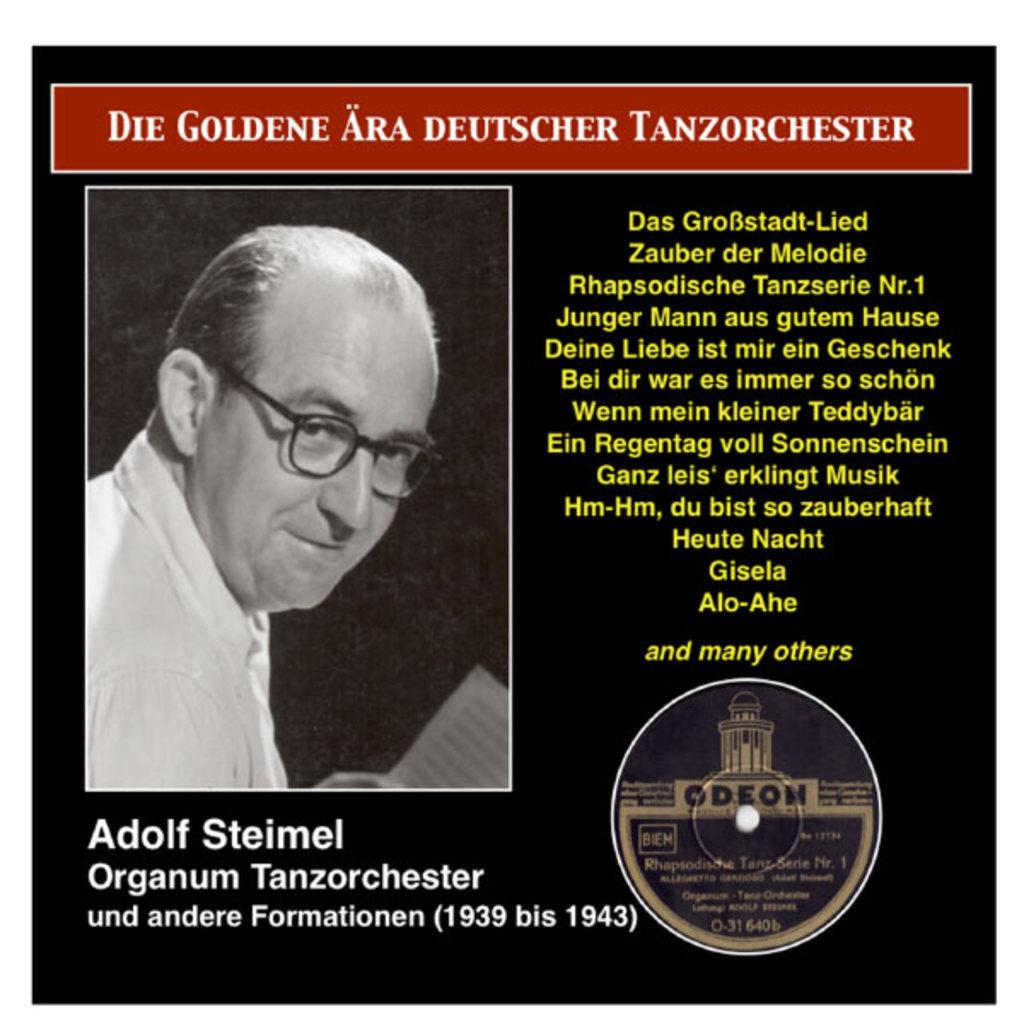What is present in the image? There is a poster in the image. What can be seen in the picture on the poster? The picture on the poster is a black and white image of a person. What else is featured on the poster besides the image? There is text on the poster. What type of advice does the person in the poster give to others? There is no indication in the image that the person in the poster is giving advice to others. 